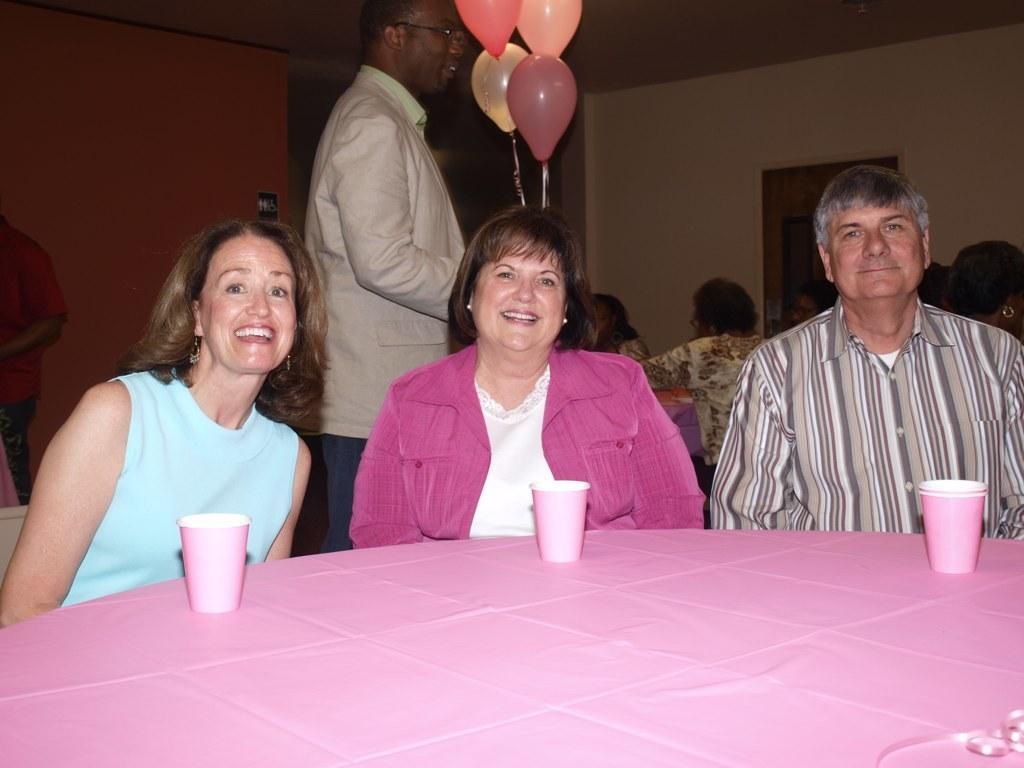Please provide a concise description of this image. there is a pink table on which there are pink glasses. people are seated on chairs. behind them a person is standing wearing suit, holding balloons. people are seated at the back. there is a white wall at the back. 